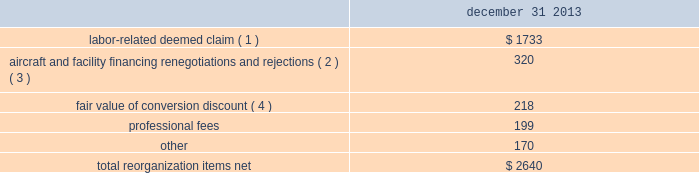Table of contents notes to consolidated financial statements of american airlines , inc .
Certificate of incorporation ( the certificate of incorporation ) contains transfer restrictions applicable to certain substantial stockholders .
Although the purpose of these transfer restrictions is to prevent an ownership change from occurring , there can be no assurance that an ownership change will not occur even with these transfer restrictions .
A copy of the certificate of incorporation was attached as exhibit 3.1 to a current report on form 8-k filed by aag with the sec on december 9 , 2013 .
Reorganization items , net reorganization items refer to revenues , expenses ( including professional fees ) , realized gains and losses and provisions for losses that are realized or incurred in the chapter 11 cases .
The table summarizes the components included in reorganization items , net on the consolidated statement of operations for the year ended december 31 , 2013 ( in millions ) : december 31 .
( 1 ) in exchange for employees 2019 contributions to the successful reorganization , including agreeing to reductions in pay and benefits , american agreed in the plan to provide each employee group a deemed claim , which was used to provide a distribution of a portion of the equity of the reorganized entity to those employees .
Each employee group received a deemed claim amount based upon a portion of the value of cost savings provided by that group through reductions to pay and benefits as well as through certain work rule changes .
The total value of this deemed claim was approximately $ 1.7 billion .
( 2 ) amounts include allowed claims ( claims approved by the bankruptcy court ) and estimated allowed claims relating to ( i ) the rejection or modification of financings related to aircraft and ( ii ) entry of orders treated as unsecured claims with respect to facility agreements supporting certain issuances of special facility revenue bonds .
The debtors recorded an estimated claim associated with the rejection or modification of a financing or facility agreement when the applicable motion was filed with the bankruptcy court to reject or modify such financing or facility agreement and the debtors believed that it was probable the motion would be approved , and there was sufficient information to estimate the claim .
( 3 ) pursuant to the plan , the debtors agreed to allow certain post-petition unsecured claims on obligations .
As a result , during the year ended december 31 , 2013 , american recorded reorganization charges to adjust estimated allowed claim amounts previously recorded on rejected special facility revenue bonds of $ 180 million , allowed general unsecured claims related to the 1990 and 1994 series of special facility revenue bonds that financed certain improvements at john f .
Kennedy international airport ( jfk ) , and rejected bonds that financed certain improvements at chicago o 2019hare international airport ( ord ) , which are included in the table above .
( 4 ) the plan allowed unsecured creditors receiving aag series a preferred stock a conversion discount of 3.5% ( 3.5 % ) .
Accordingly , american recorded the fair value of such discount upon the confirmation of the plan by the bankruptcy court. .
What portion of the total net reorganization items are related to professional fees? 
Computations: (199 / 2640)
Answer: 0.07538. 